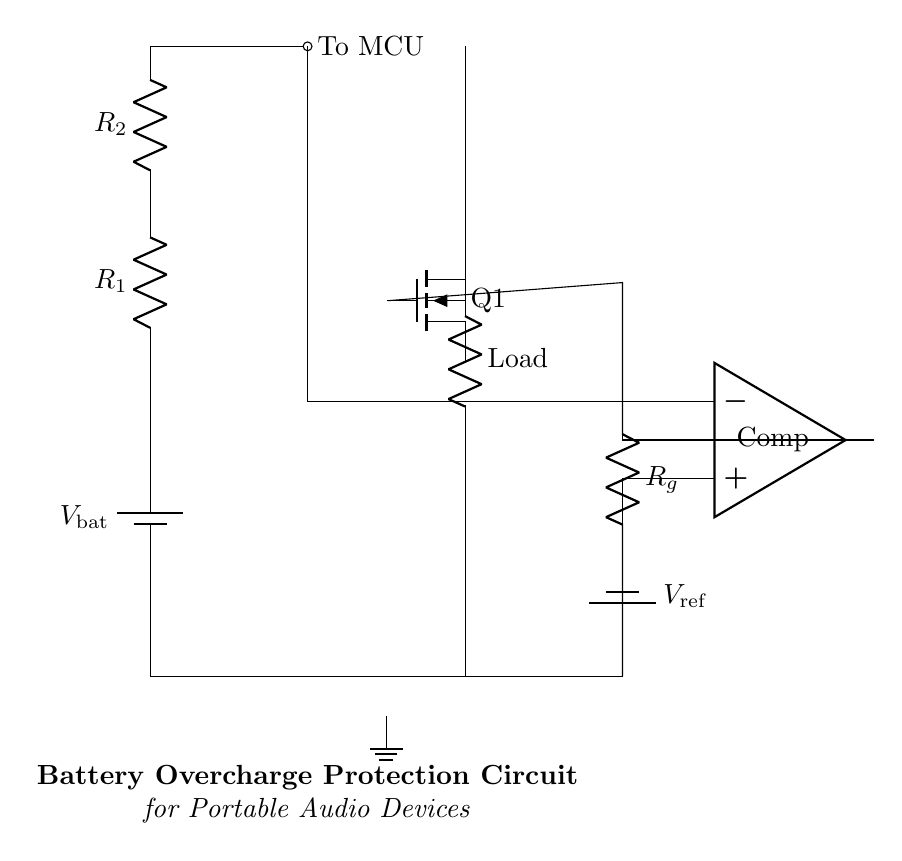What type of component is Q1? Q1 is a Field Effect Transistor (NFET), which can be identified by its symbol in the diagram. It is labeled as "Q1" and typically represents the switching element in the circuit.
Answer: NFET What do R1 and R2 form? R1 and R2 are arranged in series and create a voltage divider, which can be deduced from their connection in series with a node leading to the MCU. This setup divides the input voltage for appropriate signal levels.
Answer: Voltage divider What is the purpose of the comparator in this circuit? The comparator compares the output voltage from the voltage divider created by R1 and R2 against a reference voltage from the "V_ref" battery. Its output will control the gate of the NFET to prevent overcharging.
Answer: Overcharge detection What is the reference voltage in this circuit? The reference voltage is denoted as "V_ref." It's mentioned in the circuit where it connects to the non-inverting terminal of the comparator, indicating that it is an external voltage that the comparator uses to make decisions.
Answer: V_ref What happens when the output of the comparator goes high? When the comparator outputs a high signal, it turns the NFET "Q1" on, allowing current to flow to the load. This situation indicates that the voltage from the battery is above the threshold set by the reference voltage, triggering overcharge protection.
Answer: Q1 is turned on How does the protection mechanism work in this circuit? The circuit monitors the battery voltage through the voltage divider (R1 and R2). If the voltage exceeds the reference voltage, the comparator activates the NFET, disconnecting the load and preventing overcharge. This systematic approach ensures that the charging stops when the battery is full to prevent damage.
Answer: Disconnect load 